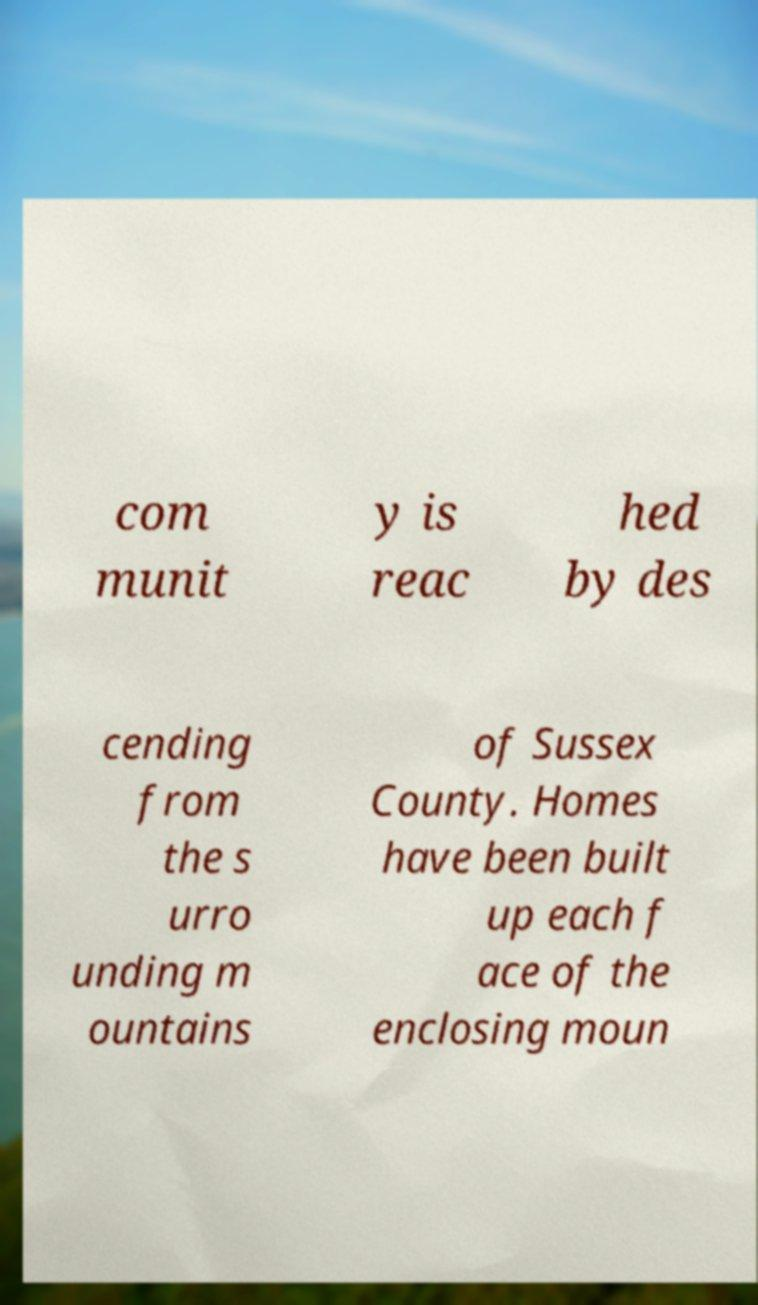Can you read and provide the text displayed in the image?This photo seems to have some interesting text. Can you extract and type it out for me? com munit y is reac hed by des cending from the s urro unding m ountains of Sussex County. Homes have been built up each f ace of the enclosing moun 